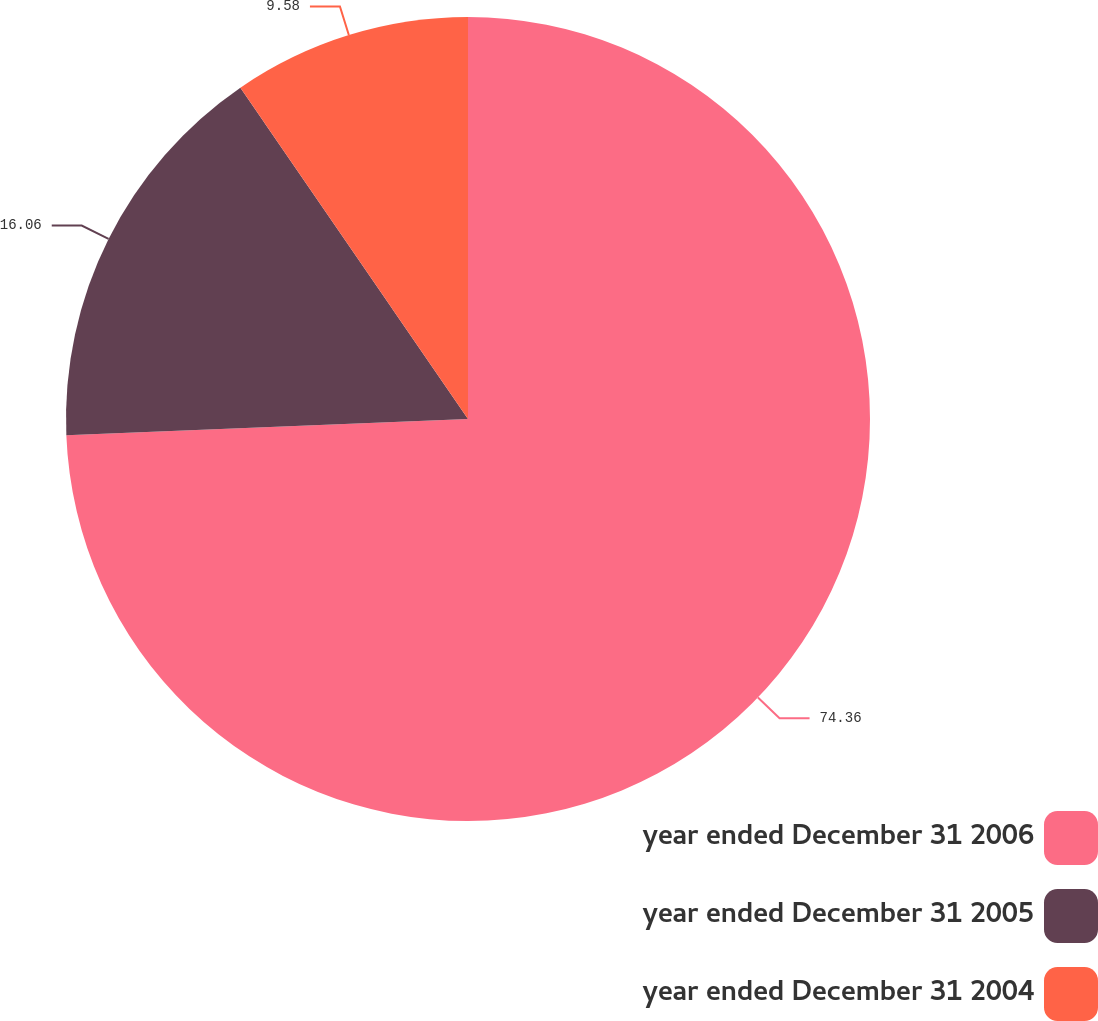Convert chart to OTSL. <chart><loc_0><loc_0><loc_500><loc_500><pie_chart><fcel>year ended December 31 2006<fcel>year ended December 31 2005<fcel>year ended December 31 2004<nl><fcel>74.36%<fcel>16.06%<fcel>9.58%<nl></chart> 